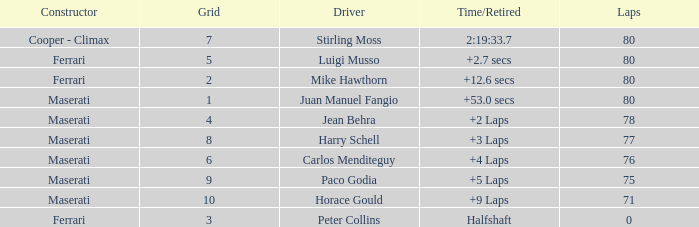I'm looking to parse the entire table for insights. Could you assist me with that? {'header': ['Constructor', 'Grid', 'Driver', 'Time/Retired', 'Laps'], 'rows': [['Cooper - Climax', '7', 'Stirling Moss', '2:19:33.7', '80'], ['Ferrari', '5', 'Luigi Musso', '+2.7 secs', '80'], ['Ferrari', '2', 'Mike Hawthorn', '+12.6 secs', '80'], ['Maserati', '1', 'Juan Manuel Fangio', '+53.0 secs', '80'], ['Maserati', '4', 'Jean Behra', '+2 Laps', '78'], ['Maserati', '8', 'Harry Schell', '+3 Laps', '77'], ['Maserati', '6', 'Carlos Menditeguy', '+4 Laps', '76'], ['Maserati', '9', 'Paco Godia', '+5 Laps', '75'], ['Maserati', '10', 'Horace Gould', '+9 Laps', '71'], ['Ferrari', '3', 'Peter Collins', 'Halfshaft', '0']]} What were the lowest laps of Luigi Musso driving a Ferrari with a Grid larger than 2? 80.0. 